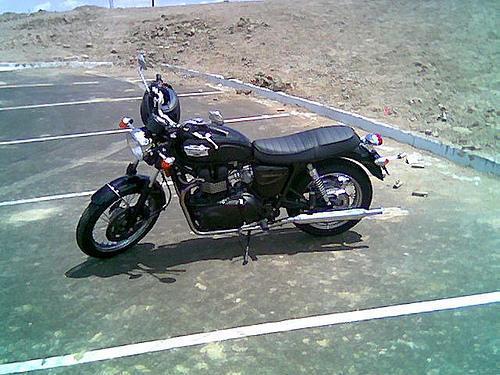How many motorcycles are there?
Give a very brief answer. 1. 